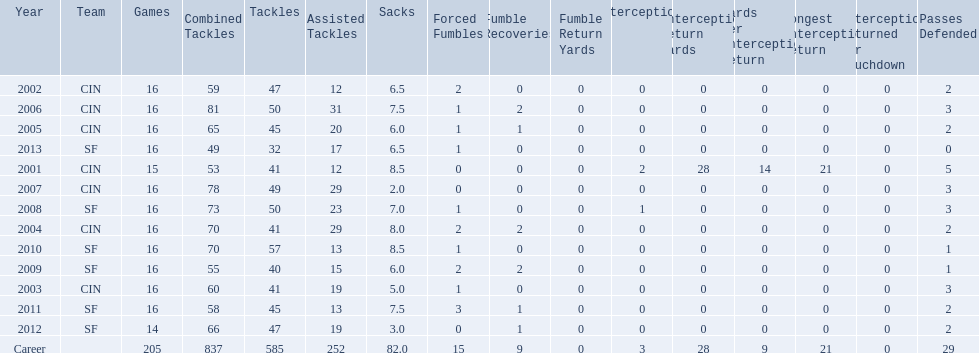How many years did he play where he did not recover a fumble? 7. 